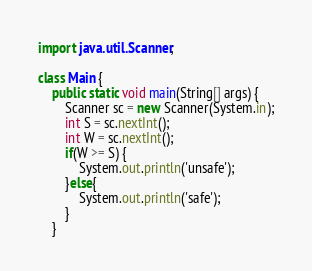<code> <loc_0><loc_0><loc_500><loc_500><_Java_>import java.util.Scanner;
 
class Main {
    public static void main(String[] args) {
        Scanner sc = new Scanner(System.in);
        int S = sc.nextInt();
        int W = sc.nextInt();
        if(W >= S) {
            System.out.println('unsafe');
        }else{
            System.out.println('safe');
        }
    }</code> 